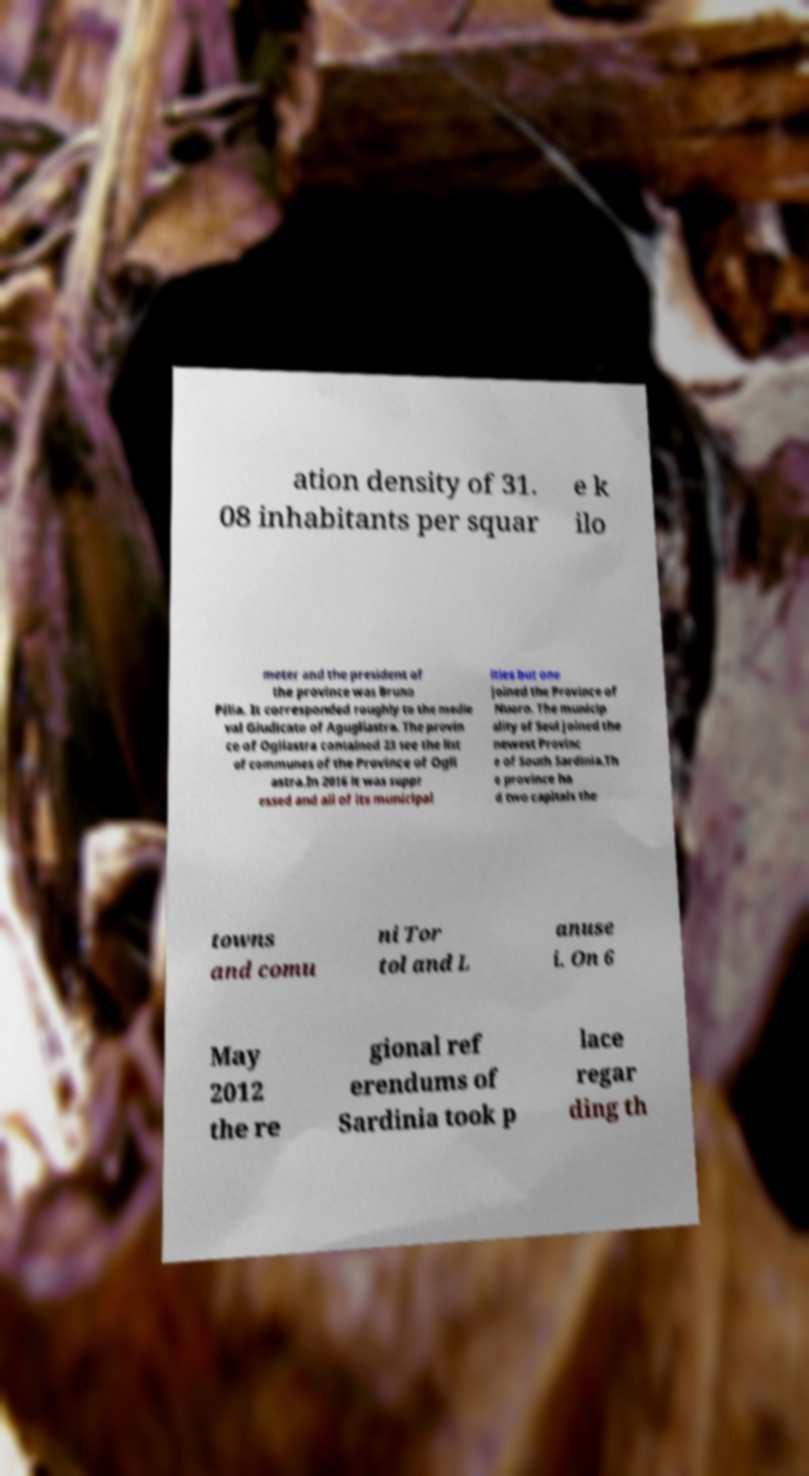Please read and relay the text visible in this image. What does it say? ation density of 31. 08 inhabitants per squar e k ilo meter and the president of the province was Bruno Pilia. It corresponded roughly to the medie val Giudicato of Agugliastra. The provin ce of Ogliastra contained 23 see the list of communes of the Province of Ogli astra.In 2016 it was suppr essed and all of its municipal ities but one joined the Province of Nuoro. The municip ality of Seui joined the newest Provinc e of South Sardinia.Th e province ha d two capitals the towns and comu ni Tor tol and L anuse i. On 6 May 2012 the re gional ref erendums of Sardinia took p lace regar ding th 